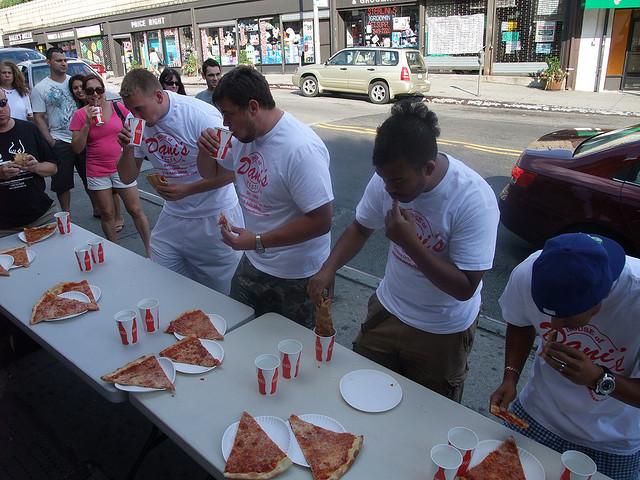How many people are participating in the eating contest?
Answer briefly. 4. What are they eating?
Quick response, please. Pizza. Who will finish the contest first?
Give a very brief answer. Blue hat guy. What Pizza Company delivered this pizza?
Concise answer only. Dani's. What is the primary color of the shirts?
Give a very brief answer. White. Does this look like a eating contest?
Answer briefly. Yes. What time of day is it?
Be succinct. Afternoon. 